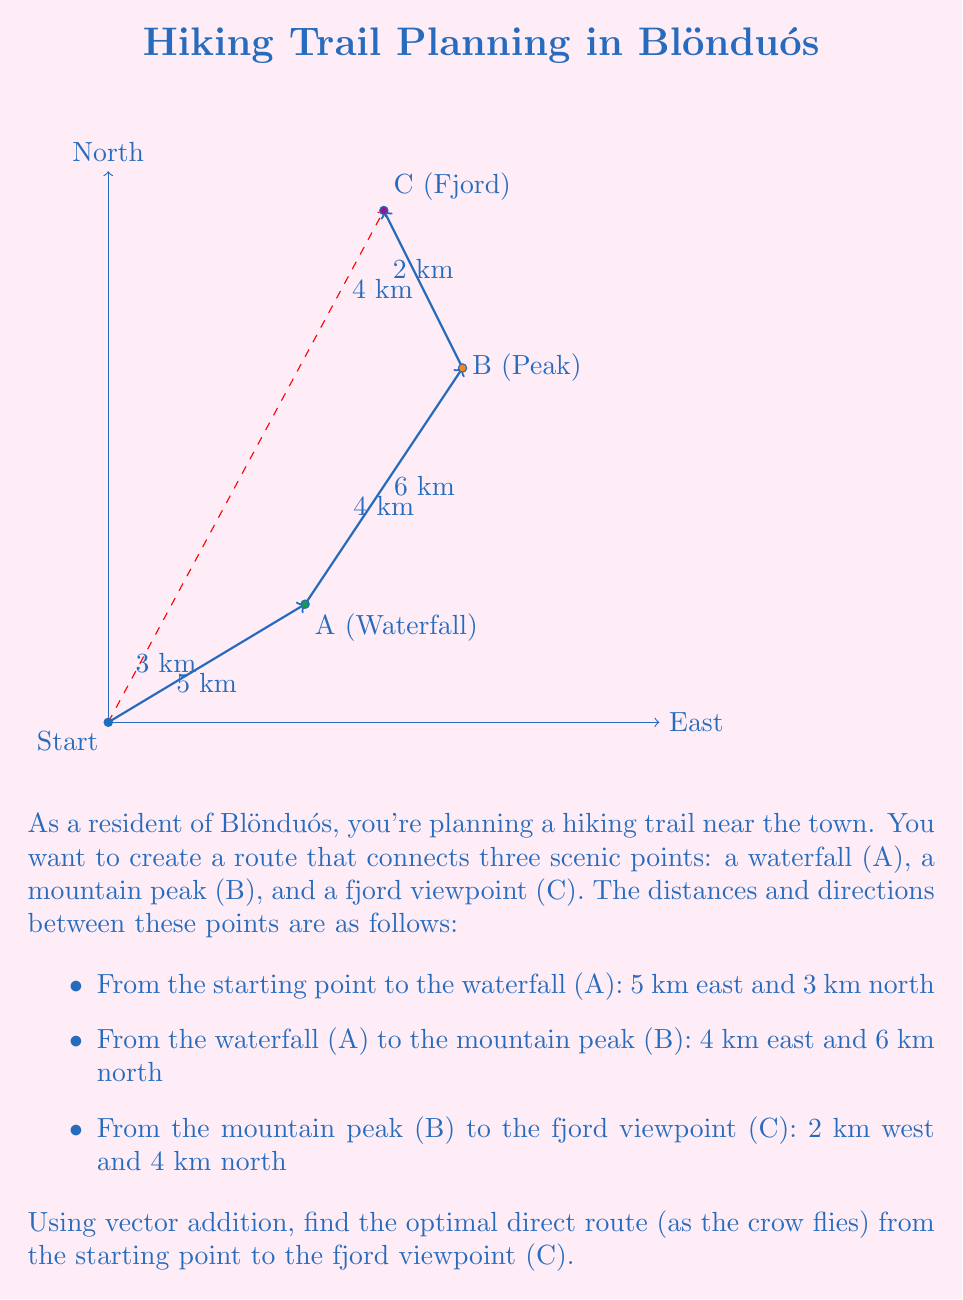Give your solution to this math problem. Let's solve this problem step by step using vector addition:

1) First, let's define our vectors:
   $\vec{v_1}$ = vector from start to A = $\langle 5, 3 \rangle$
   $\vec{v_2}$ = vector from A to B = $\langle 4, 6 \rangle$
   $\vec{v_3}$ = vector from B to C = $\langle -2, 4 \rangle$

2) The optimal route from start to C is the sum of these vectors:
   $\vec{v_{total}} = \vec{v_1} + \vec{v_2} + \vec{v_3}$

3) Let's add these vectors:
   $\vec{v_{total}} = \langle 5, 3 \rangle + \langle 4, 6 \rangle + \langle -2, 4 \rangle$

4) Adding the x-components: $5 + 4 + (-2) = 7$
   Adding the y-components: $3 + 6 + 4 = 13$

5) Therefore, $\vec{v_{total}} = \langle 7, 13 \rangle$

6) This vector represents the direct route from the starting point to point C.

7) To find the distance of this route, we can use the Pythagorean theorem:
   distance = $\sqrt{7^2 + 13^2} = \sqrt{49 + 169} = \sqrt{218} \approx 14.76$ km

8) The direction can be found using the arctangent function:
   $\theta = \arctan(\frac{13}{7}) \approx 61.7°$ from east

Therefore, the optimal direct route is approximately 14.76 km in a direction 61.7° north of east.
Answer: $\langle 7, 13 \rangle$, 14.76 km at 61.7° NE 